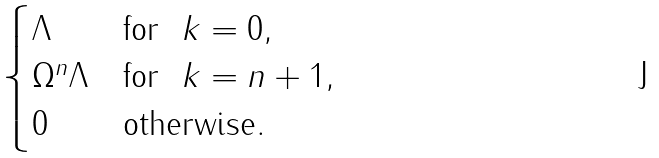Convert formula to latex. <formula><loc_0><loc_0><loc_500><loc_500>\begin{cases} \Lambda & \text {for \ } k = 0 , \\ \Omega ^ { n } \Lambda & \text {for \ } k = n + 1 , \\ 0 & \text {otherwise} . \end{cases}</formula> 